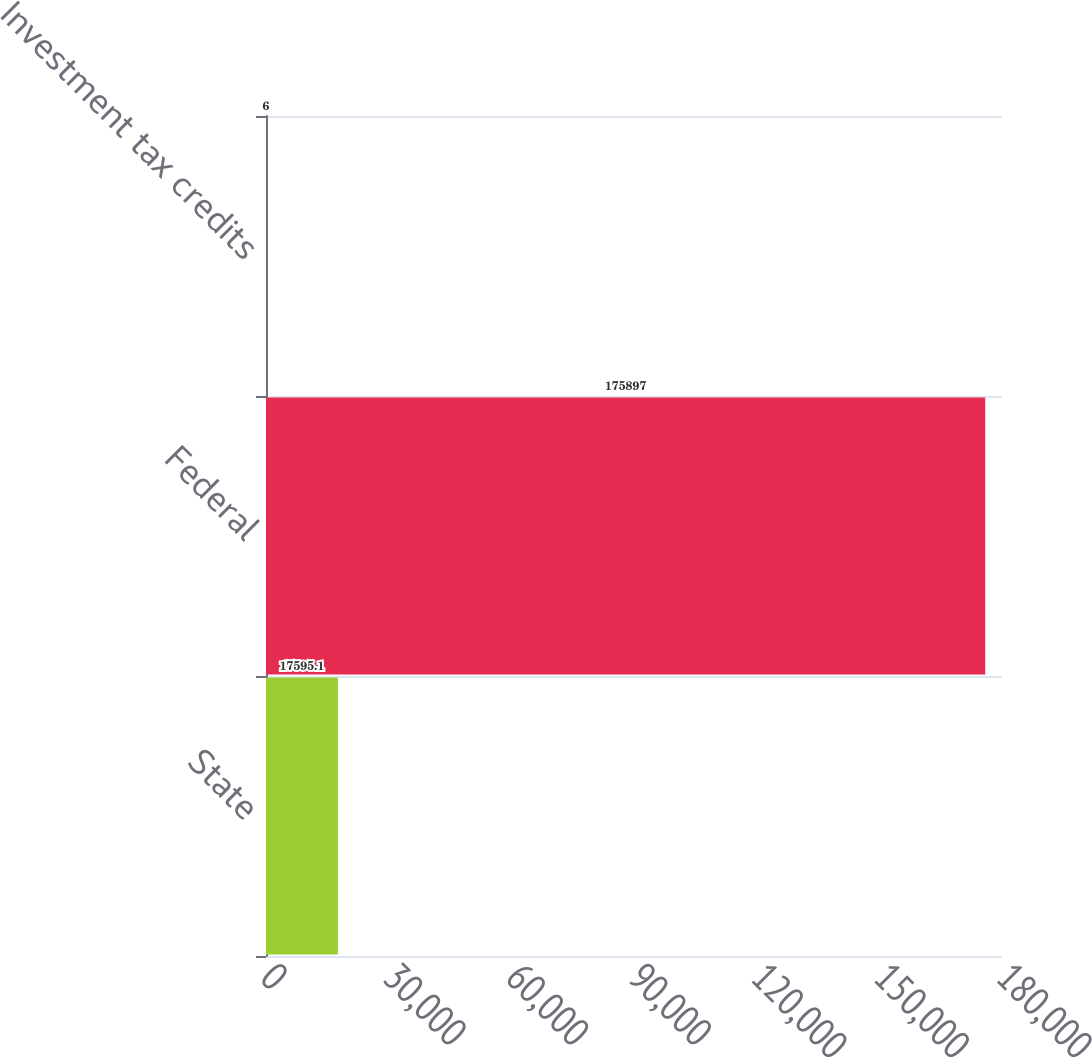Convert chart to OTSL. <chart><loc_0><loc_0><loc_500><loc_500><bar_chart><fcel>State<fcel>Federal<fcel>Investment tax credits<nl><fcel>17595.1<fcel>175897<fcel>6<nl></chart> 